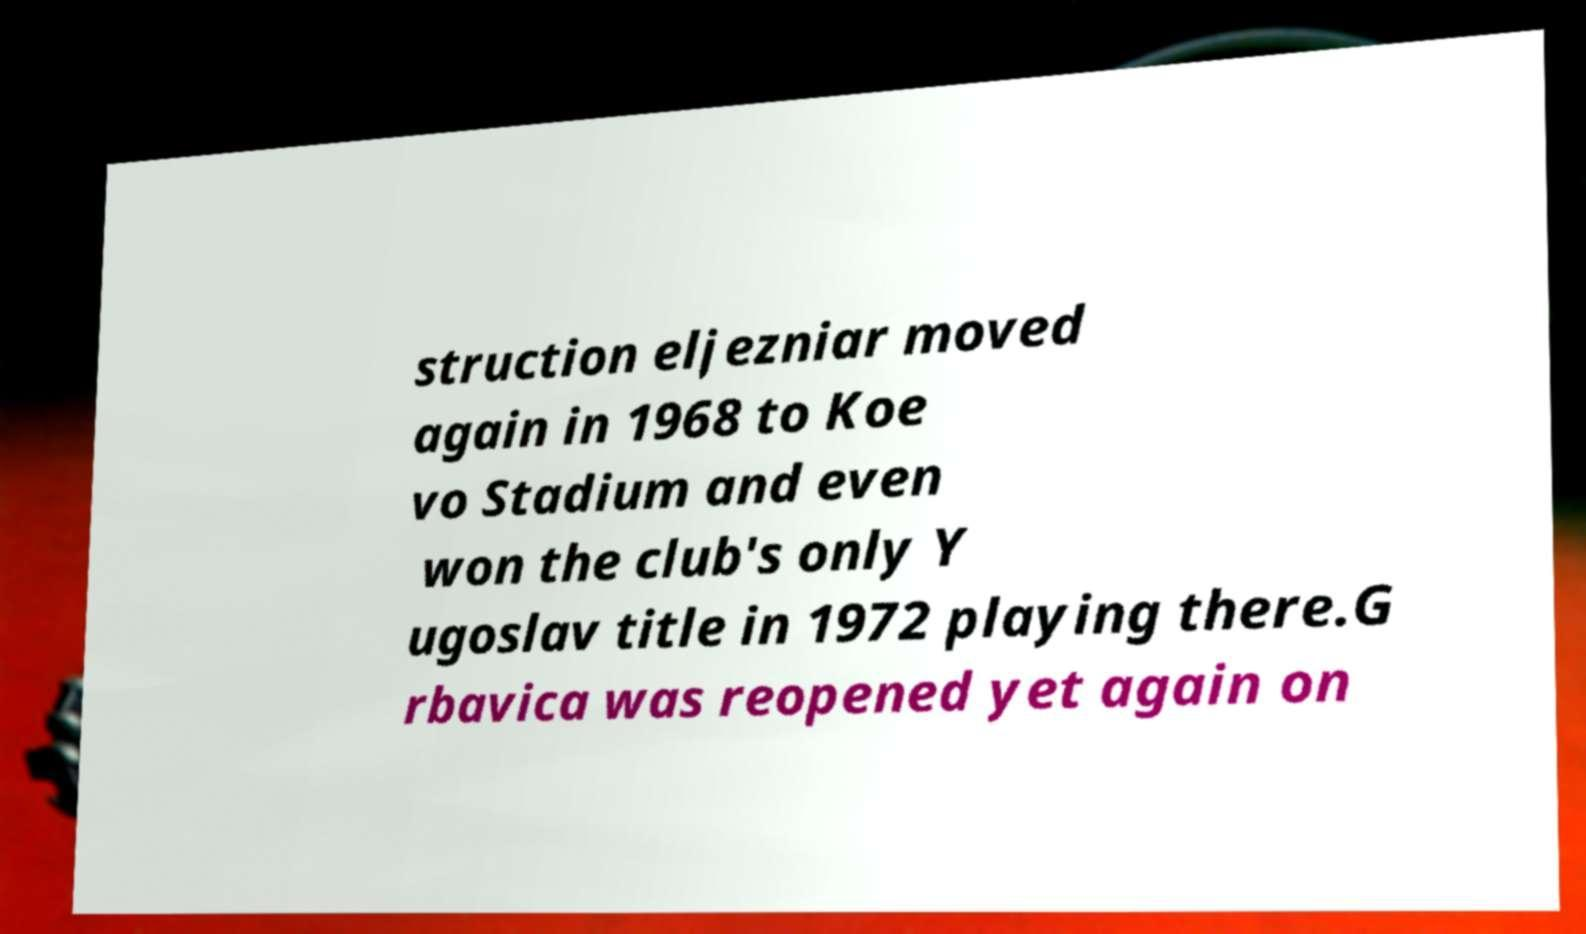What messages or text are displayed in this image? I need them in a readable, typed format. struction eljezniar moved again in 1968 to Koe vo Stadium and even won the club's only Y ugoslav title in 1972 playing there.G rbavica was reopened yet again on 